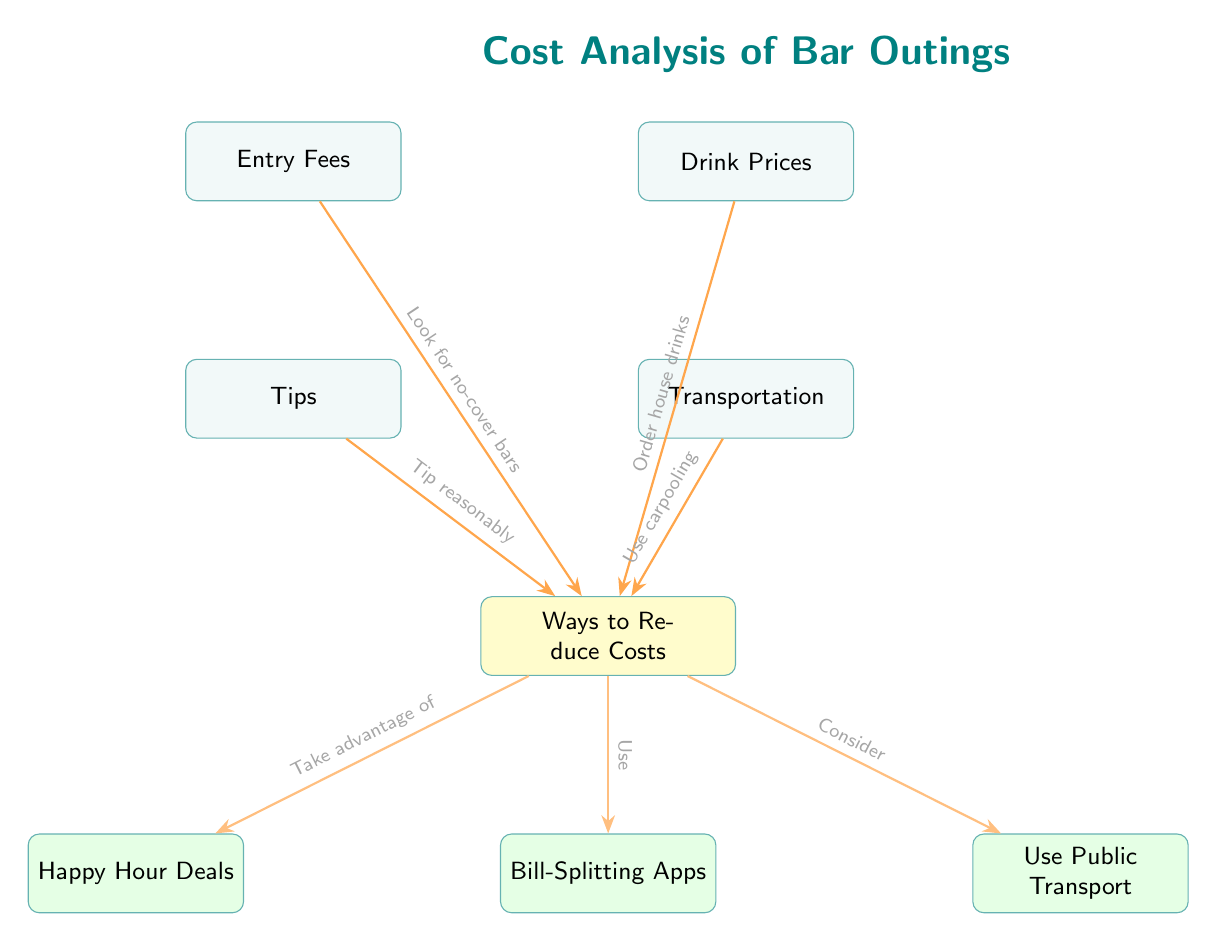What are the four main cost components of bar outings? The diagram includes four main nodes: Entry Fees, Drink Prices, Tips, and Transportation. Each of these represents a different cost associated with going to a bar.
Answer: Entry Fees, Drink Prices, Tips, Transportation Which cost component can be reduced by looking for no-cover bars? The diagram states a direct relationship where looking for no-cover bars influences the Entry Fees. This indicates that Entry Fees can be minimized this way.
Answer: Entry Fees What tip is suggested to minimize costs associated with drinks? The diagram suggests ordering house drinks as a way to reduce costs that are related to Drink Prices.
Answer: Order house drinks What is one method mentioned for reducing tips? According to the diagram, the way to reduce tips is to tip reasonably. This implies managing how much one tips while still providing a tip.
Answer: Tip reasonably How many ways to reduce costs are listed in the diagram? The diagram features four distinct 'Ways to Reduce Costs' nodes, which include Happy Hour Deals, Bill-Splitting Apps, and Use Public Transport.
Answer: Four What type of transport is recommended for cost reduction? The diagram includes the recommendation to use Public Transport as one of the ways to minimize transportation costs associated with bar outings.
Answer: Public Transport Which advice specifically relates to reducing costs from transportation? The suggestion in the diagram to Use carpooling impacts the Transportation cost. This implies sharing rides as a method to save on transportation expenses.
Answer: Use carpooling What is connected to the 'Ways to Reduce Costs' section in reference to drink deals? Happy Hour Deals are shown as a method connected to 'Ways to Reduce Costs,' indicating that they can offer a way to save on drink prices.
Answer: Happy Hour Deals What relationship exists between Drink Prices and cost-reduction strategies? The diagram shows that Drink Prices can be minimized by ordering house drinks; this indicates a direct relationship of influence on cost-reduction strategies.
Answer: Order house drinks 